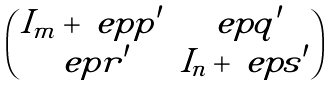Convert formula to latex. <formula><loc_0><loc_0><loc_500><loc_500>\begin{pmatrix} I _ { m } + \ e p p ^ { \prime } & \ e p q ^ { \prime } \\ \ e p r ^ { \prime } & I _ { n } + \ e p s ^ { \prime } \end{pmatrix}</formula> 